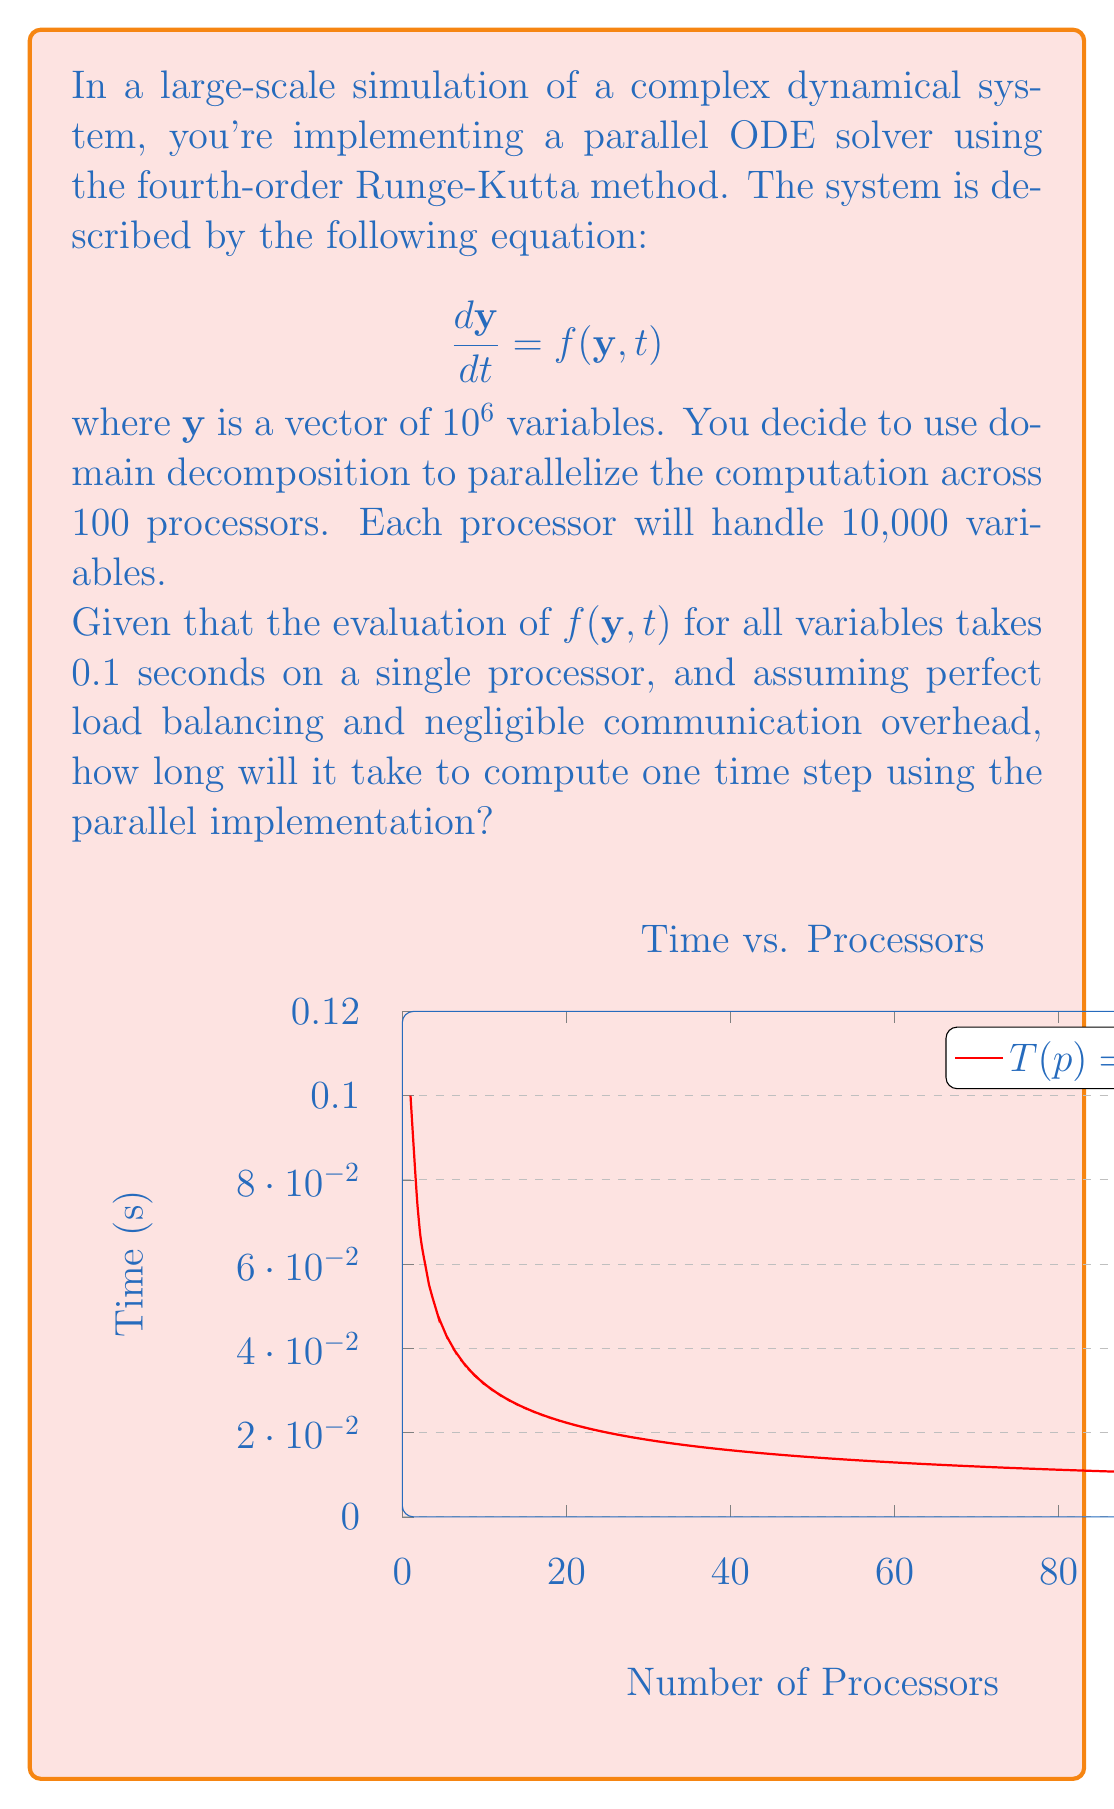Solve this math problem. Let's approach this step-by-step:

1) First, recall that the fourth-order Runge-Kutta method requires four evaluations of $f(\mathbf{y}, t)$ per time step:

   $$\begin{aligned}
   k_1 &= f(\mathbf{y}_n, t_n) \\
   k_2 &= f(\mathbf{y}_n + \frac{h}{2}k_1, t_n + \frac{h}{2}) \\
   k_3 &= f(\mathbf{y}_n + \frac{h}{2}k_2, t_n + \frac{h}{2}) \\
   k_4 &= f(\mathbf{y}_n + hk_3, t_n + h)
   \end{aligned}$$

2) In the serial implementation, each evaluation takes 0.1 seconds. So, one time step would take:

   $$4 \times 0.1 = 0.4 \text{ seconds}$$

3) Now, with domain decomposition across 100 processors, each processor handles 10,000 variables instead of $10^6$.

4) Assuming perfect load balancing, the time for each evaluation of $f(\mathbf{y}, t)$ on each processor will be reduced by a factor of 100:

   $$0.1 / 100 = 0.001 \text{ seconds}$$

5) Therefore, the time for one Runge-Kutta step in the parallel implementation will be:

   $$4 \times 0.001 = 0.004 \text{ seconds}$$

6) This assumes negligible communication overhead, which is often not realistic but is part of the problem statement.
Answer: 0.004 seconds 